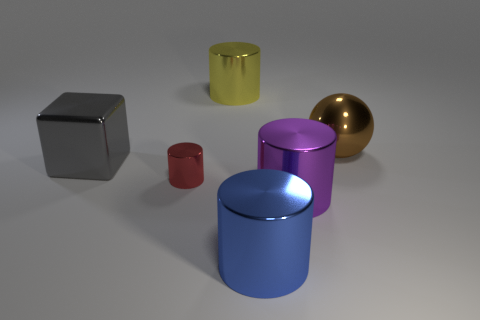Add 1 tiny red shiny cylinders. How many objects exist? 7 Subtract all cubes. How many objects are left? 5 Add 2 large purple cylinders. How many large purple cylinders exist? 3 Subtract 0 cyan spheres. How many objects are left? 6 Subtract all small gray rubber spheres. Subtract all big objects. How many objects are left? 1 Add 6 red shiny objects. How many red shiny objects are left? 7 